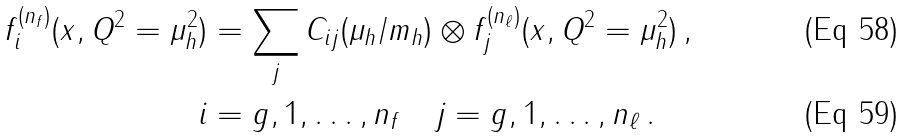<formula> <loc_0><loc_0><loc_500><loc_500>f ^ { ( n _ { f } ) } _ { i } ( x , Q ^ { 2 } = \mu _ { h } ^ { 2 } ) & = \sum _ { j } C _ { i j } ( \mu _ { h } / m _ { h } ) \otimes f ^ { ( n _ { \ell } ) } _ { j } ( x , Q ^ { 2 } = \mu _ { h } ^ { 2 } ) \, , \\ i & = g , 1 , \dots , n _ { f } \quad j = g , 1 , \dots , n _ { \ell } \, .</formula> 